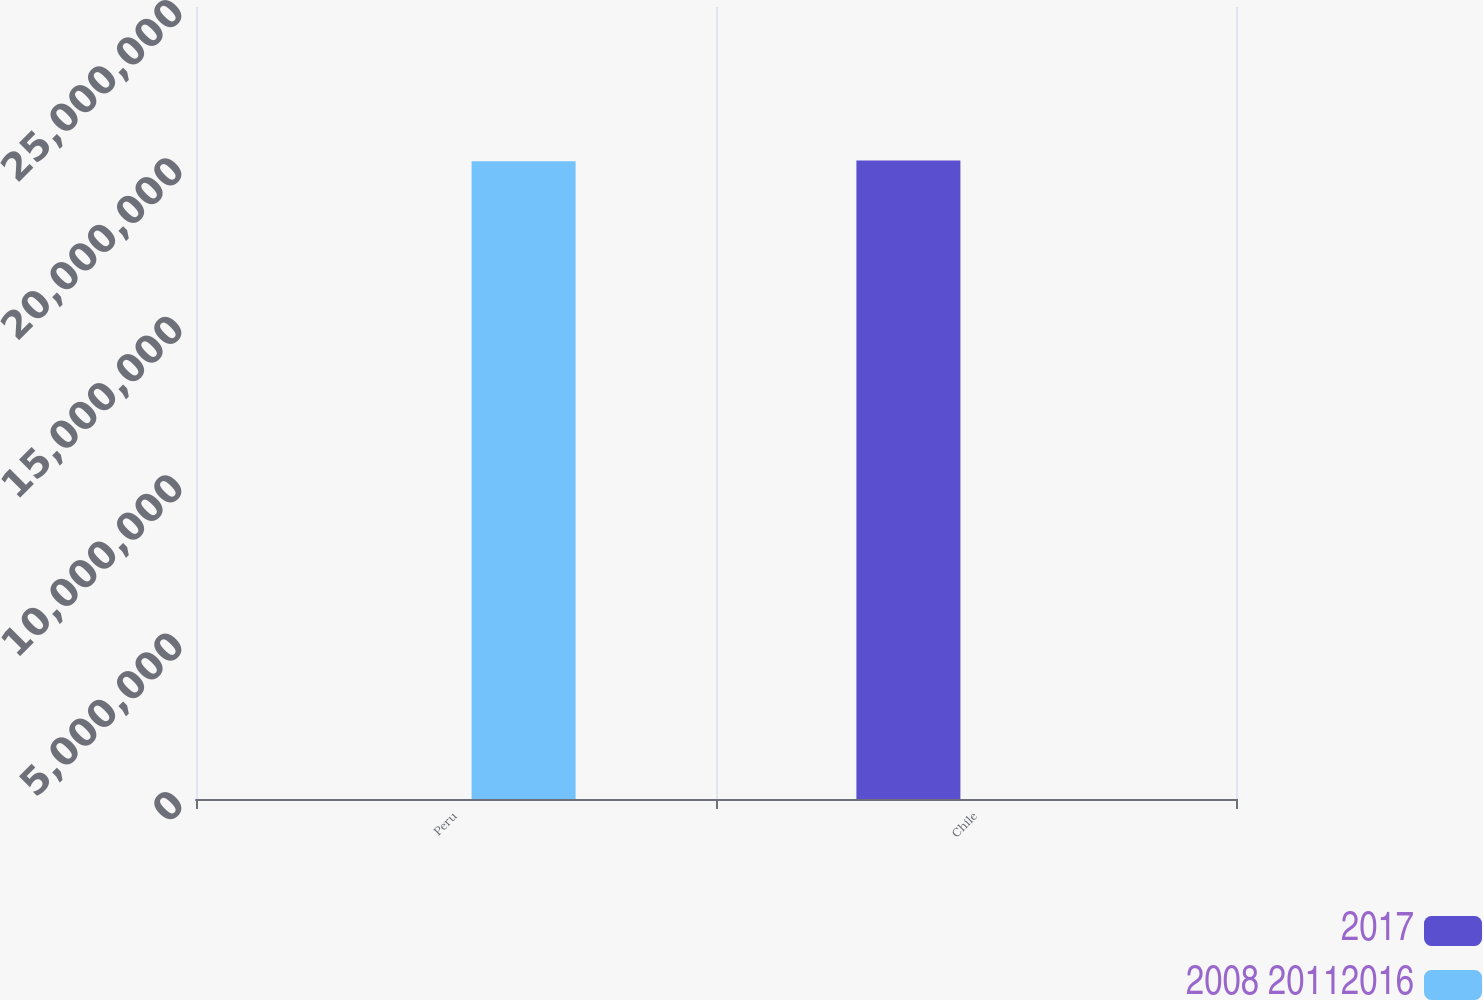Convert chart. <chart><loc_0><loc_0><loc_500><loc_500><stacked_bar_chart><ecel><fcel>Peru<fcel>Chile<nl><fcel>2017<fcel>2012<fcel>2.0152e+07<nl><fcel>2008 20112016<fcel>2.0132e+07<fcel>2017<nl></chart> 